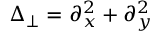Convert formula to latex. <formula><loc_0><loc_0><loc_500><loc_500>\Delta _ { \perp } = \partial _ { x } ^ { 2 } + \partial _ { y } ^ { 2 }</formula> 